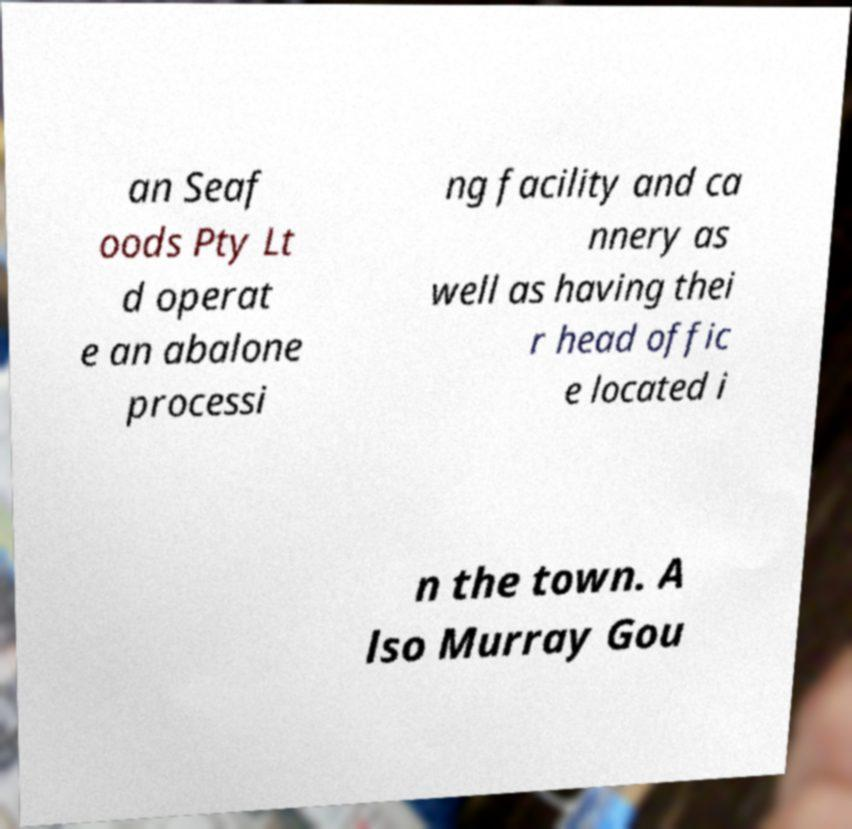For documentation purposes, I need the text within this image transcribed. Could you provide that? an Seaf oods Pty Lt d operat e an abalone processi ng facility and ca nnery as well as having thei r head offic e located i n the town. A lso Murray Gou 